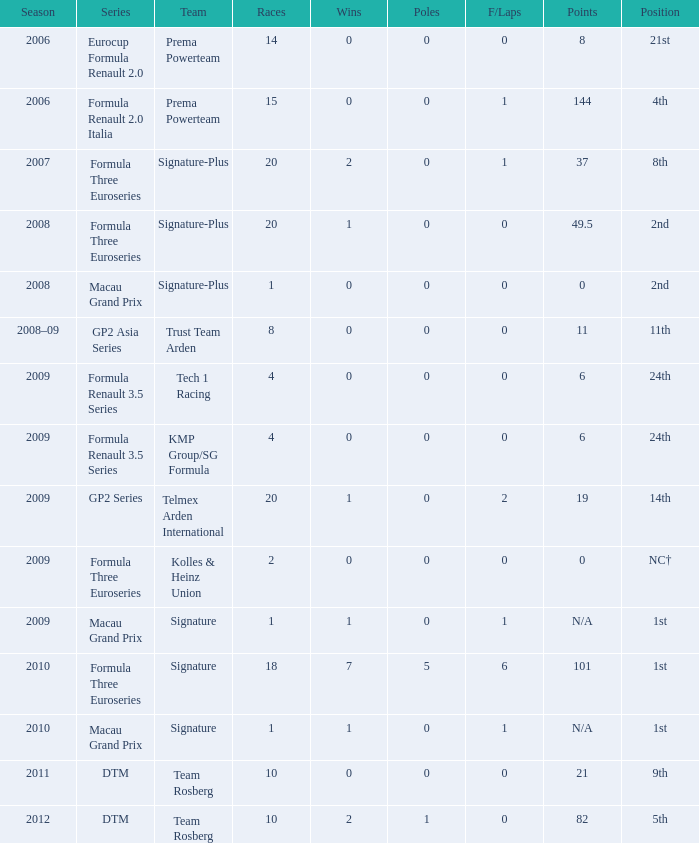For the 2009 season, how many poles with more than 0 f/laps are present in 2 or more races? 0.0. 